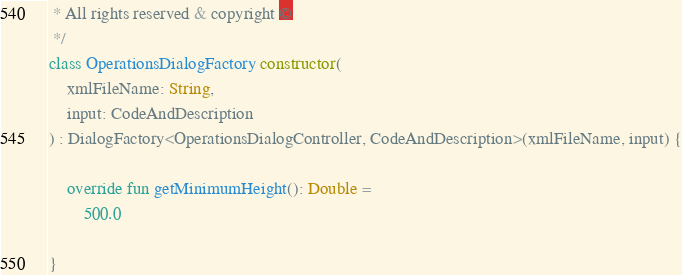Convert code to text. <code><loc_0><loc_0><loc_500><loc_500><_Kotlin_> * All rights reserved & copyright ©
 */
class OperationsDialogFactory constructor(
    xmlFileName: String,
    input: CodeAndDescription
) : DialogFactory<OperationsDialogController, CodeAndDescription>(xmlFileName, input) {

    override fun getMinimumHeight(): Double =
        500.0

}</code> 